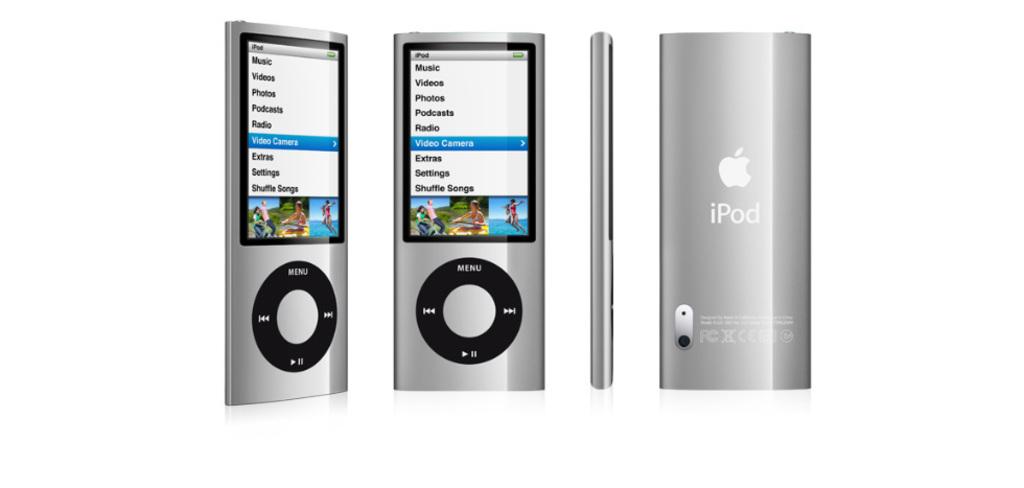What brand is this?
Provide a succinct answer. Ipod. What is the black round circle for?
Give a very brief answer. Answering does not require reading text in the image. 